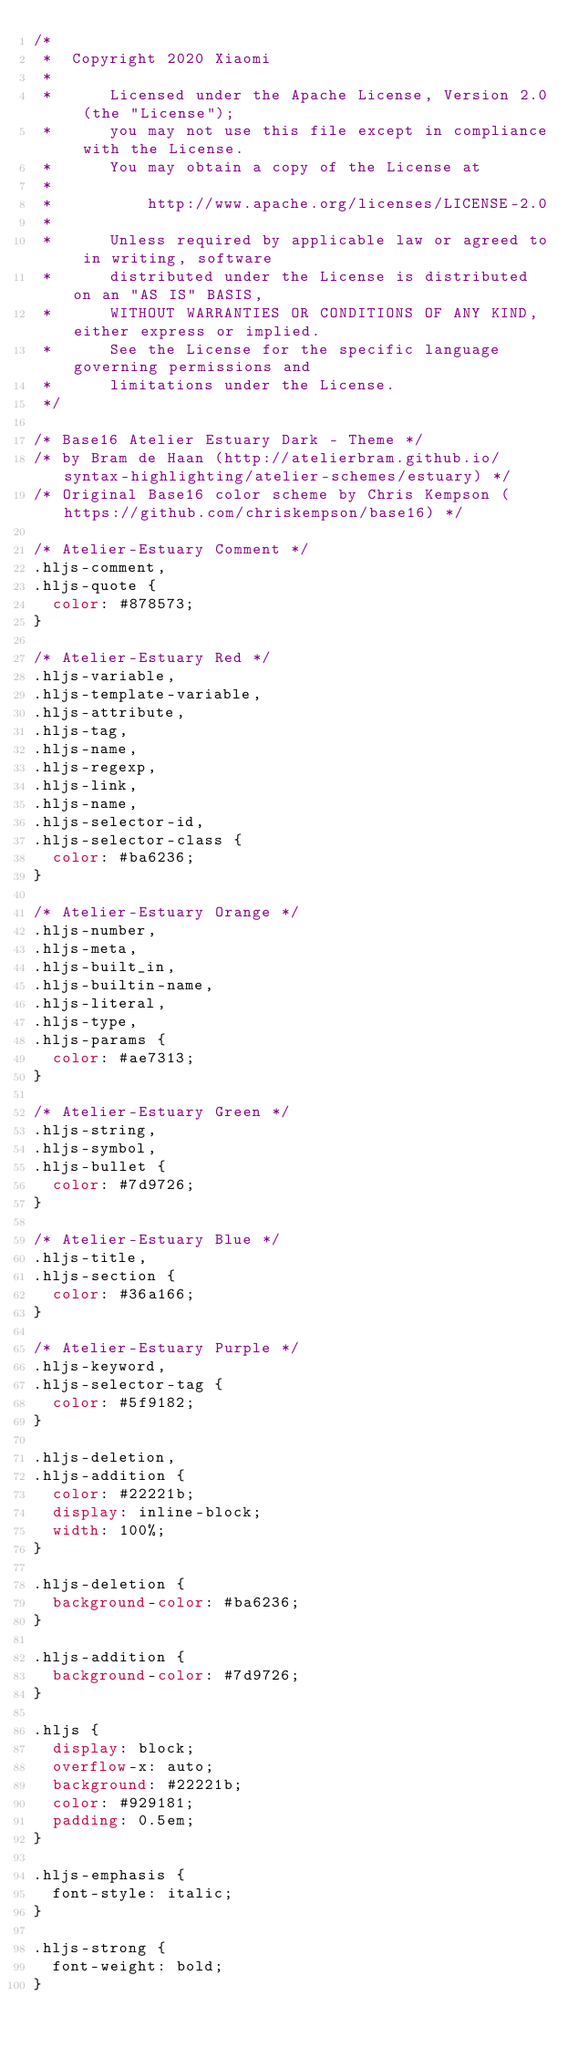<code> <loc_0><loc_0><loc_500><loc_500><_CSS_>/*
 *  Copyright 2020 Xiaomi
 *
 *      Licensed under the Apache License, Version 2.0 (the "License");
 *      you may not use this file except in compliance with the License.
 *      You may obtain a copy of the License at
 *
 *          http://www.apache.org/licenses/LICENSE-2.0
 *
 *      Unless required by applicable law or agreed to in writing, software
 *      distributed under the License is distributed on an "AS IS" BASIS,
 *      WITHOUT WARRANTIES OR CONDITIONS OF ANY KIND, either express or implied.
 *      See the License for the specific language governing permissions and
 *      limitations under the License.
 */

/* Base16 Atelier Estuary Dark - Theme */
/* by Bram de Haan (http://atelierbram.github.io/syntax-highlighting/atelier-schemes/estuary) */
/* Original Base16 color scheme by Chris Kempson (https://github.com/chriskempson/base16) */

/* Atelier-Estuary Comment */
.hljs-comment,
.hljs-quote {
  color: #878573;
}

/* Atelier-Estuary Red */
.hljs-variable,
.hljs-template-variable,
.hljs-attribute,
.hljs-tag,
.hljs-name,
.hljs-regexp,
.hljs-link,
.hljs-name,
.hljs-selector-id,
.hljs-selector-class {
  color: #ba6236;
}

/* Atelier-Estuary Orange */
.hljs-number,
.hljs-meta,
.hljs-built_in,
.hljs-builtin-name,
.hljs-literal,
.hljs-type,
.hljs-params {
  color: #ae7313;
}

/* Atelier-Estuary Green */
.hljs-string,
.hljs-symbol,
.hljs-bullet {
  color: #7d9726;
}

/* Atelier-Estuary Blue */
.hljs-title,
.hljs-section {
  color: #36a166;
}

/* Atelier-Estuary Purple */
.hljs-keyword,
.hljs-selector-tag {
  color: #5f9182;
}

.hljs-deletion,
.hljs-addition {
  color: #22221b;
  display: inline-block;
  width: 100%;
}

.hljs-deletion {
  background-color: #ba6236;
}

.hljs-addition {
  background-color: #7d9726;
}

.hljs {
  display: block;
  overflow-x: auto;
  background: #22221b;
  color: #929181;
  padding: 0.5em;
}

.hljs-emphasis {
  font-style: italic;
}

.hljs-strong {
  font-weight: bold;
}
</code> 